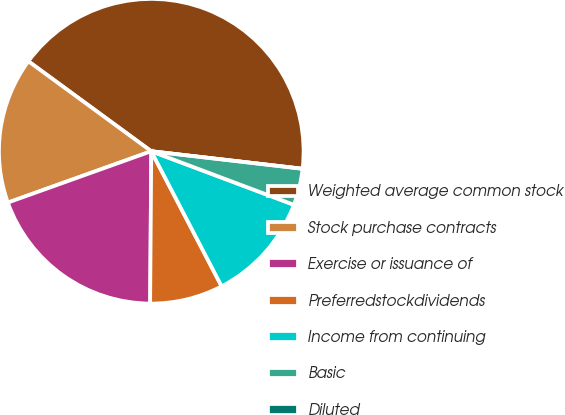Convert chart. <chart><loc_0><loc_0><loc_500><loc_500><pie_chart><fcel>Weighted average common stock<fcel>Stock purchase contracts<fcel>Exercise or issuance of<fcel>Preferredstockdividends<fcel>Income from continuing<fcel>Basic<fcel>Diluted<nl><fcel>41.78%<fcel>15.53%<fcel>19.41%<fcel>7.76%<fcel>11.64%<fcel>3.88%<fcel>0.0%<nl></chart> 